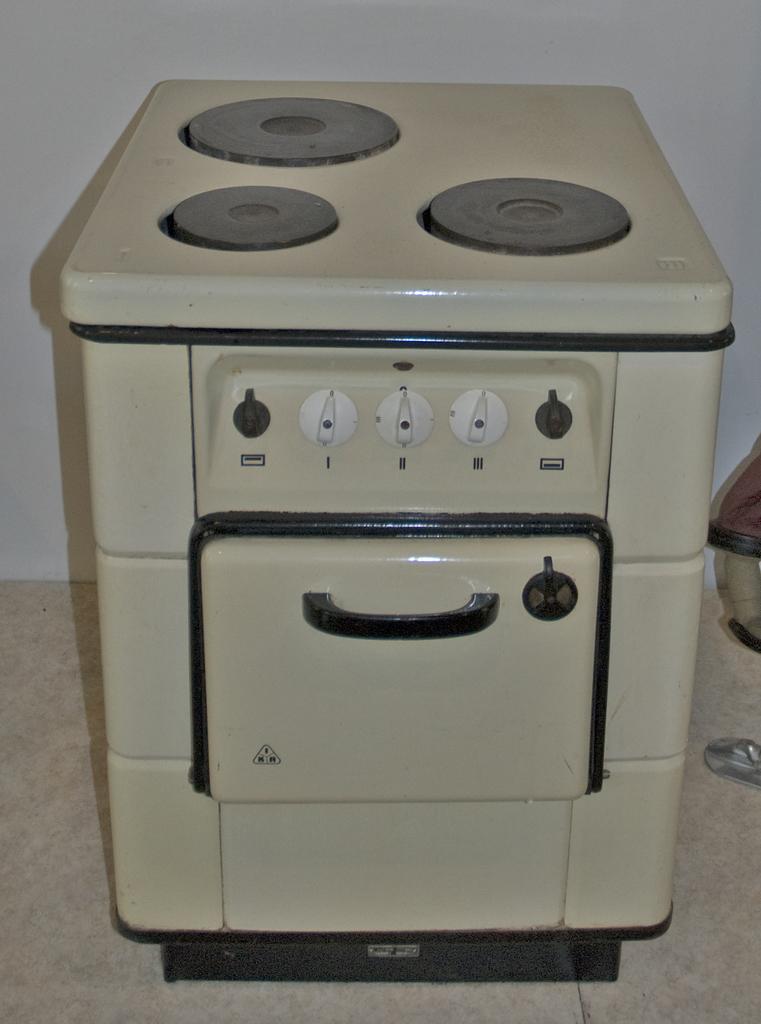Please provide a concise description of this image. In this picture we can observe a kitchen stove which is in white color. This is placed on the floor. In the background we can observe a white color wall. 